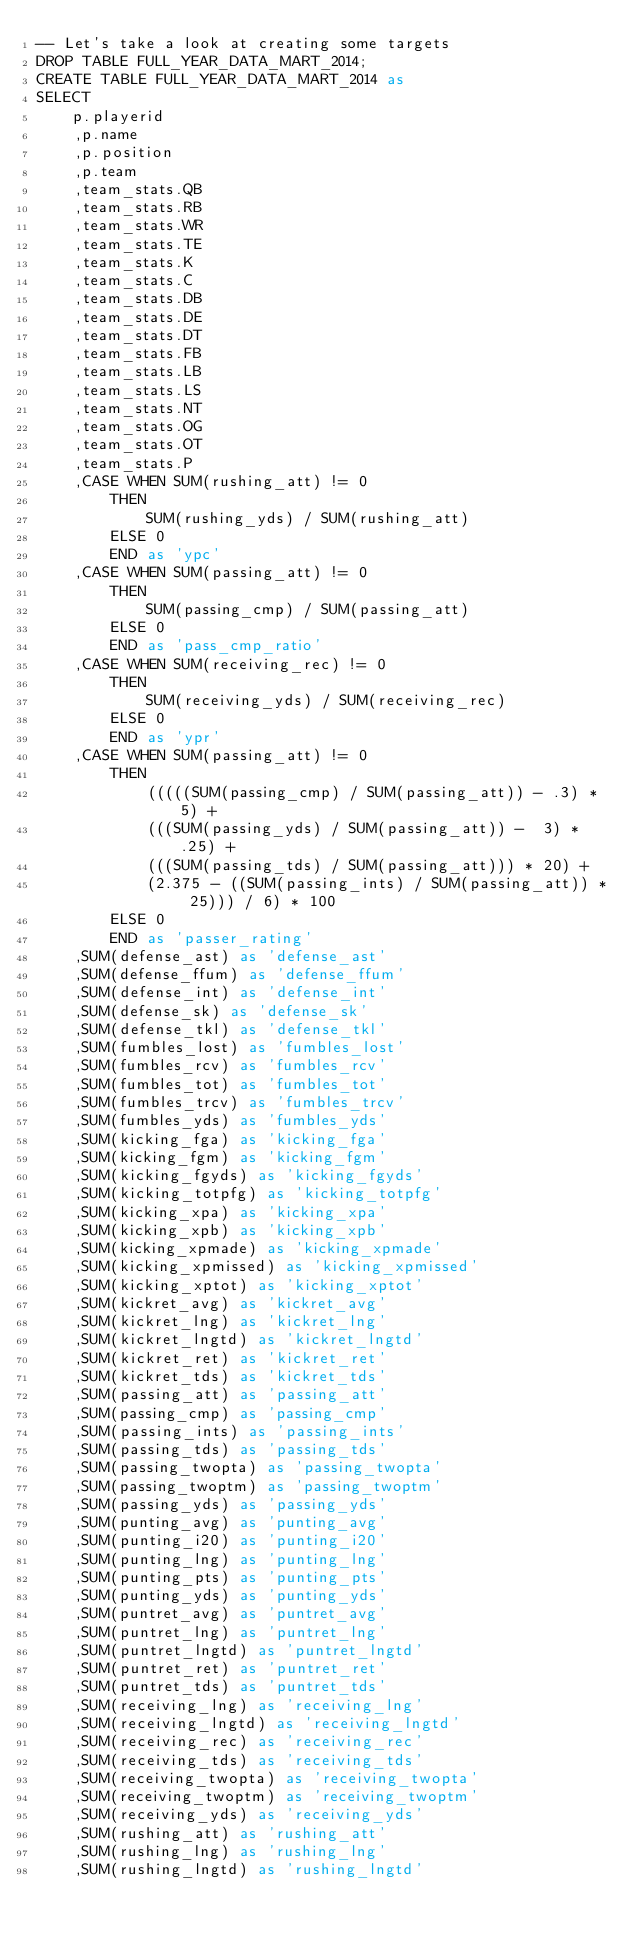Convert code to text. <code><loc_0><loc_0><loc_500><loc_500><_SQL_>-- Let's take a look at creating some targets
DROP TABLE FULL_YEAR_DATA_MART_2014;
CREATE TABLE FULL_YEAR_DATA_MART_2014 as 
SELECT
    p.playerid
    ,p.name
    ,p.position
    ,p.team
    ,team_stats.QB
    ,team_stats.RB
    ,team_stats.WR
    ,team_stats.TE
    ,team_stats.K
    ,team_stats.C 
    ,team_stats.DB 
    ,team_stats.DE 
    ,team_stats.DT 
    ,team_stats.FB
    ,team_stats.LB 
    ,team_stats.LS 
    ,team_stats.NT 
    ,team_stats.OG
    ,team_stats.OT 
    ,team_stats.P 
    ,CASE WHEN SUM(rushing_att) != 0
        THEN 
            SUM(rushing_yds) / SUM(rushing_att)
        ELSE 0 
        END as 'ypc'
    ,CASE WHEN SUM(passing_att) != 0
        THEN
            SUM(passing_cmp) / SUM(passing_att)
        ELSE 0
        END as 'pass_cmp_ratio'
    ,CASE WHEN SUM(receiving_rec) != 0
        THEN 
            SUM(receiving_yds) / SUM(receiving_rec)
        ELSE 0
        END as 'ypr'
    ,CASE WHEN SUM(passing_att) != 0
        THEN
            (((((SUM(passing_cmp) / SUM(passing_att)) - .3) * 5) +
            (((SUM(passing_yds) / SUM(passing_att)) -  3) * .25) +
            (((SUM(passing_tds) / SUM(passing_att))) * 20) +
            (2.375 - ((SUM(passing_ints) / SUM(passing_att)) * 25))) / 6) * 100
        ELSE 0
        END as 'passer_rating'
    ,SUM(defense_ast) as 'defense_ast'
    ,SUM(defense_ffum) as 'defense_ffum'
    ,SUM(defense_int) as 'defense_int'
    ,SUM(defense_sk) as 'defense_sk'
    ,SUM(defense_tkl) as 'defense_tkl'
    ,SUM(fumbles_lost) as 'fumbles_lost'
    ,SUM(fumbles_rcv) as 'fumbles_rcv'
    ,SUM(fumbles_tot) as 'fumbles_tot'
    ,SUM(fumbles_trcv) as 'fumbles_trcv'
    ,SUM(fumbles_yds) as 'fumbles_yds'
    ,SUM(kicking_fga) as 'kicking_fga'
    ,SUM(kicking_fgm) as 'kicking_fgm'
    ,SUM(kicking_fgyds) as 'kicking_fgyds'
    ,SUM(kicking_totpfg) as 'kicking_totpfg'
    ,SUM(kicking_xpa) as 'kicking_xpa'
    ,SUM(kicking_xpb) as 'kicking_xpb'
    ,SUM(kicking_xpmade) as 'kicking_xpmade'
    ,SUM(kicking_xpmissed) as 'kicking_xpmissed'
    ,SUM(kicking_xptot) as 'kicking_xptot'
    ,SUM(kickret_avg) as 'kickret_avg'
    ,SUM(kickret_lng) as 'kickret_lng'
    ,SUM(kickret_lngtd) as 'kickret_lngtd'
    ,SUM(kickret_ret) as 'kickret_ret'
    ,SUM(kickret_tds) as 'kickret_tds'
    ,SUM(passing_att) as 'passing_att'
    ,SUM(passing_cmp) as 'passing_cmp'
    ,SUM(passing_ints) as 'passing_ints'
    ,SUM(passing_tds) as 'passing_tds'
    ,SUM(passing_twopta) as 'passing_twopta'
    ,SUM(passing_twoptm) as 'passing_twoptm'
    ,SUM(passing_yds) as 'passing_yds'
    ,SUM(punting_avg) as 'punting_avg'
    ,SUM(punting_i20) as 'punting_i20'
    ,SUM(punting_lng) as 'punting_lng'
    ,SUM(punting_pts) as 'punting_pts'
    ,SUM(punting_yds) as 'punting_yds'
    ,SUM(puntret_avg) as 'puntret_avg'
    ,SUM(puntret_lng) as 'puntret_lng'
    ,SUM(puntret_lngtd) as 'puntret_lngtd'
    ,SUM(puntret_ret) as 'puntret_ret'
    ,SUM(puntret_tds) as 'puntret_tds'
    ,SUM(receiving_lng) as 'receiving_lng'
    ,SUM(receiving_lngtd) as 'receiving_lngtd'
    ,SUM(receiving_rec) as 'receiving_rec'
    ,SUM(receiving_tds) as 'receiving_tds'
    ,SUM(receiving_twopta) as 'receiving_twopta'
    ,SUM(receiving_twoptm) as 'receiving_twoptm'
    ,SUM(receiving_yds) as 'receiving_yds'
    ,SUM(rushing_att) as 'rushing_att'
    ,SUM(rushing_lng) as 'rushing_lng'
    ,SUM(rushing_lngtd) as 'rushing_lngtd'</code> 